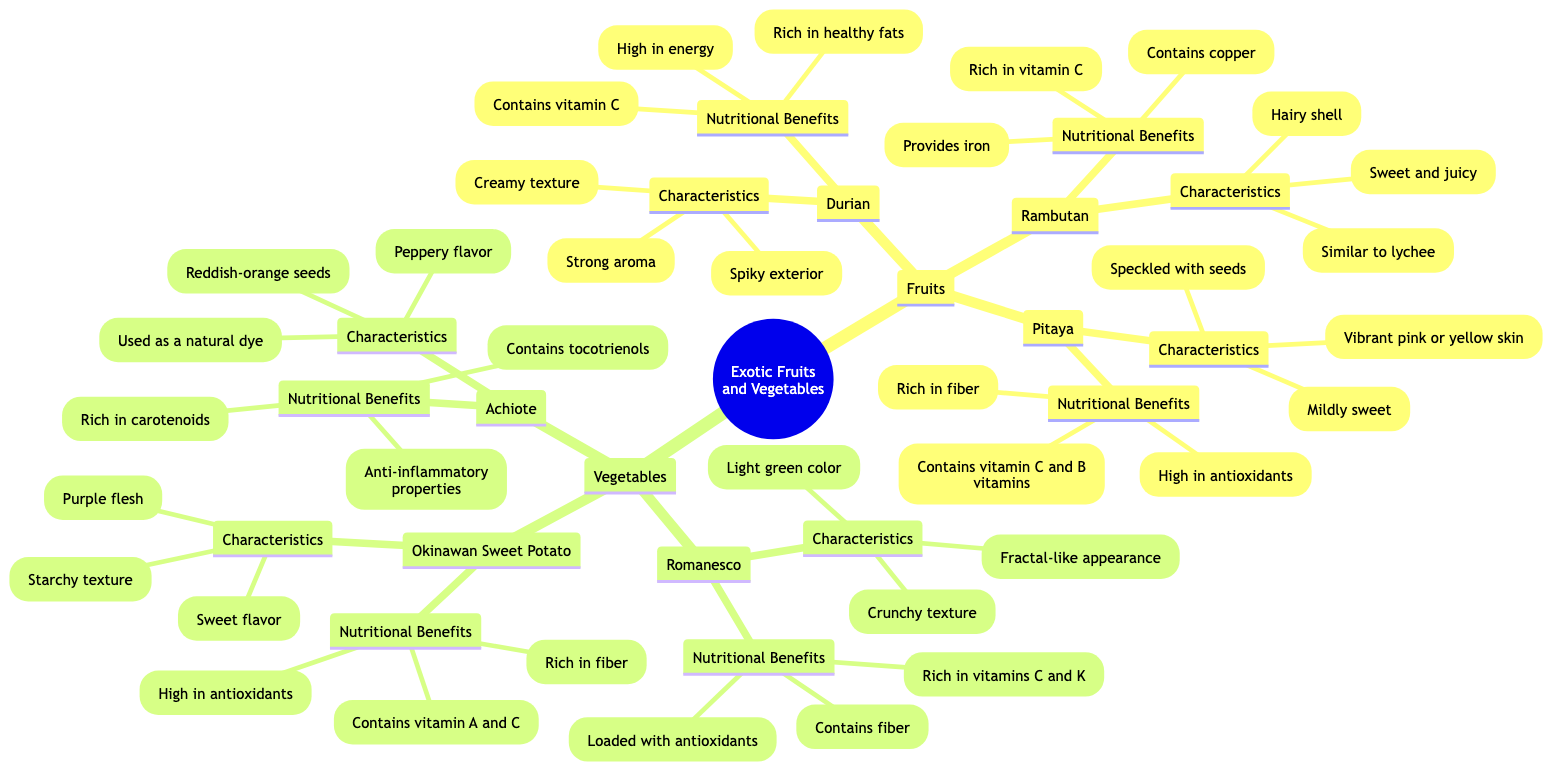What is the central node of the concept map? The central node of the diagram is explicitly mentioned as "Exotic Fruits and Vegetables."
Answer: Exotic Fruits and Vegetables Name one characteristic of the Durian. The diagram lists several characteristics of the Durian, including "Spiky exterior," "Strong aroma," and "Creamy texture." Any one of these could be the answer.
Answer: Spiky exterior How many exotic fruits are mentioned in the diagram? By counting the fruits listed under the "Fruits" section, we see that there are three: Durian, Rambutan, and Pitaya (Dragon Fruit).
Answer: 3 What vitamin is Rambutan rich in? The nutritional benefits of Rambutan include "Rich in vitamin C," which directly answers the question.
Answer: Vitamin C Which vegetable is loaded with antioxidants? The diagram states that Romanesco and Okinawan Sweet Potato are both loaded with antioxidants. However, the question asks for one specific vegetable; therefore, we can choose either.
Answer: Romanesco What is the texture of Okinawan Sweet Potato? The diagram describes the Okinawan Sweet Potato as having a "Starchy texture," which specifically answers the question about its texture.
Answer: Starchy texture How are the characteristics of Romanesco described? The characteristics listed for Romanesco include "Fractal-like appearance," "Light green color," and "Crunchy texture." Combining these gives a comprehensive description of Romanesco.
Answer: Fractal-like appearance Does Achiote have anti-inflammatory properties? The diagram indicates that one of the nutritional benefits of Achiote is its "Anti-inflammatory properties," confirming that it does possess such benefits.
Answer: Yes Which fruit is known to have a vibrant skin color? According to the diagram, Pitaya (Dragon Fruit) has "Vibrant pink or yellow skin," directly answering the question regarding vibrant skin color among fruits.
Answer: Pitaya What common nutrient do both Rambutan and Durian contain? Both Rambutan and Durian contain vitamin C as indicated in the respective nutritional benefits sections for both fruits. Thus, this nutrient is common to both.
Answer: Vitamin C 